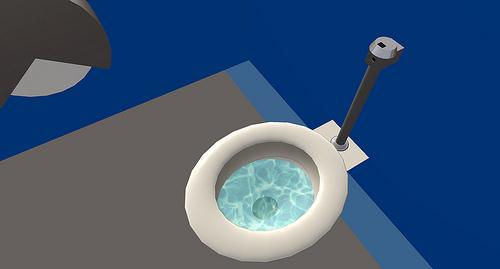In one sentence, explain the overall style of the bathroom in the image. The bathroom in the image has a modern design with blue walls, gray floor, and sleek fixtures. Describe the floor and its appearance in the image. The floor is gray, and it appears to be a smooth surface stretching under the toilet and throughout the bathroom. Explain what kind of sensor is in the image and its location. There is an electronic flush sensor mounted on a shiny metal pole, located to the right and above the toilet. Which particular feature in the toilet is notable in the image? The notable feature in the toilet is the electronic flush sensor mounted on a metal pole. Provide a brief overview of the image content. The image illustrates a computer-generated bathroom with a white toilet, blue water in the bowl, a toilet paper dispenser, an electronic flush sensor, and a gray floor. Mention the accessory found alongside the toilet in this image. A toilet paper dispenser with white toilet paper is mounted on the wall next to the toilet. Point out the major colors in the image and their corresponding objects. Major colors include white for the toilet seat, blue for the walls and water in the bowl, and gray for the floor. Describe the color and texture of the toilet seat in the image. The toilet seat is smooth and white with a round shape. Describe the color of water in the toilet bowl and the texture it appears to have. The water in the toilet bowl is blue and has a shimmering texture. Identify the primary object in this image. The primary object in the image is a white toilet seat. 